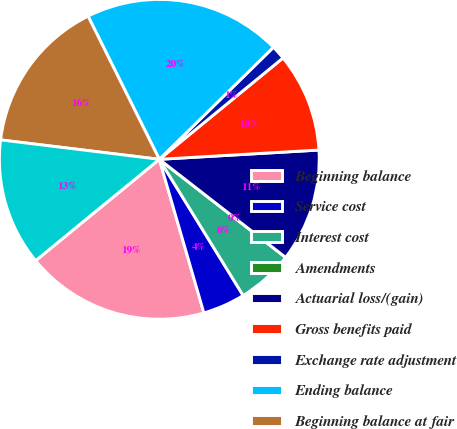<chart> <loc_0><loc_0><loc_500><loc_500><pie_chart><fcel>Beginning balance<fcel>Service cost<fcel>Interest cost<fcel>Amendments<fcel>Actuarial loss/(gain)<fcel>Gross benefits paid<fcel>Exchange rate adjustment<fcel>Ending balance<fcel>Beginning balance at fair<fcel>Actual return on plan assets<nl><fcel>18.57%<fcel>4.29%<fcel>5.71%<fcel>0.0%<fcel>11.43%<fcel>10.0%<fcel>1.43%<fcel>20.0%<fcel>15.71%<fcel>12.86%<nl></chart> 